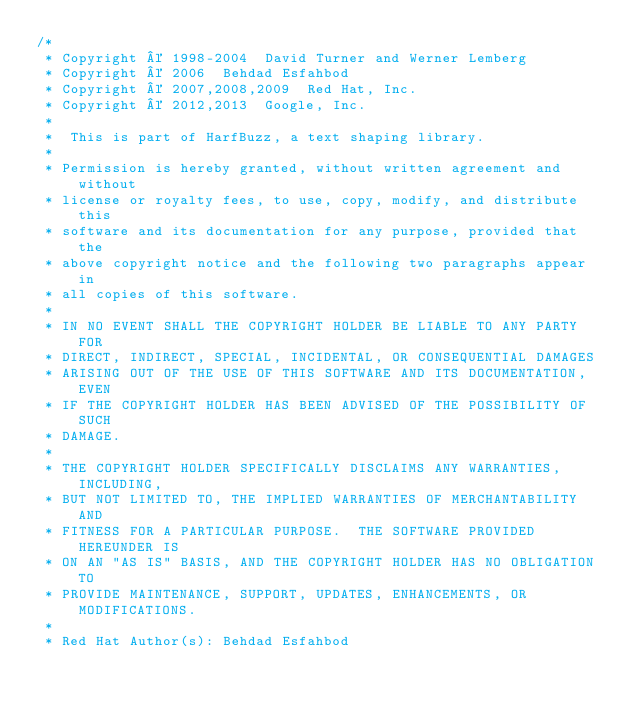<code> <loc_0><loc_0><loc_500><loc_500><_C++_>/*
 * Copyright © 1998-2004  David Turner and Werner Lemberg
 * Copyright © 2006  Behdad Esfahbod
 * Copyright © 2007,2008,2009  Red Hat, Inc.
 * Copyright © 2012,2013  Google, Inc.
 *
 *  This is part of HarfBuzz, a text shaping library.
 *
 * Permission is hereby granted, without written agreement and without
 * license or royalty fees, to use, copy, modify, and distribute this
 * software and its documentation for any purpose, provided that the
 * above copyright notice and the following two paragraphs appear in
 * all copies of this software.
 *
 * IN NO EVENT SHALL THE COPYRIGHT HOLDER BE LIABLE TO ANY PARTY FOR
 * DIRECT, INDIRECT, SPECIAL, INCIDENTAL, OR CONSEQUENTIAL DAMAGES
 * ARISING OUT OF THE USE OF THIS SOFTWARE AND ITS DOCUMENTATION, EVEN
 * IF THE COPYRIGHT HOLDER HAS BEEN ADVISED OF THE POSSIBILITY OF SUCH
 * DAMAGE.
 *
 * THE COPYRIGHT HOLDER SPECIFICALLY DISCLAIMS ANY WARRANTIES, INCLUDING,
 * BUT NOT LIMITED TO, THE IMPLIED WARRANTIES OF MERCHANTABILITY AND
 * FITNESS FOR A PARTICULAR PURPOSE.  THE SOFTWARE PROVIDED HEREUNDER IS
 * ON AN "AS IS" BASIS, AND THE COPYRIGHT HOLDER HAS NO OBLIGATION TO
 * PROVIDE MAINTENANCE, SUPPORT, UPDATES, ENHANCEMENTS, OR MODIFICATIONS.
 *
 * Red Hat Author(s): Behdad Esfahbod</code> 